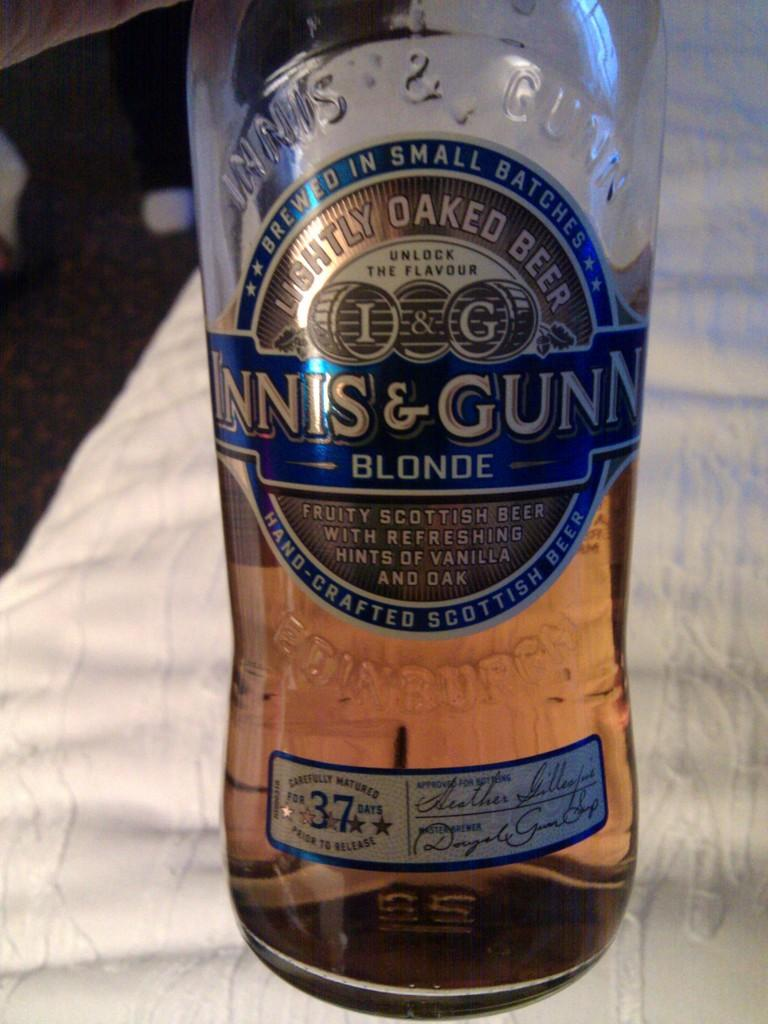<image>
Render a clear and concise summary of the photo. The bottle of alcohol shown contains fruity beer from Scotland. 